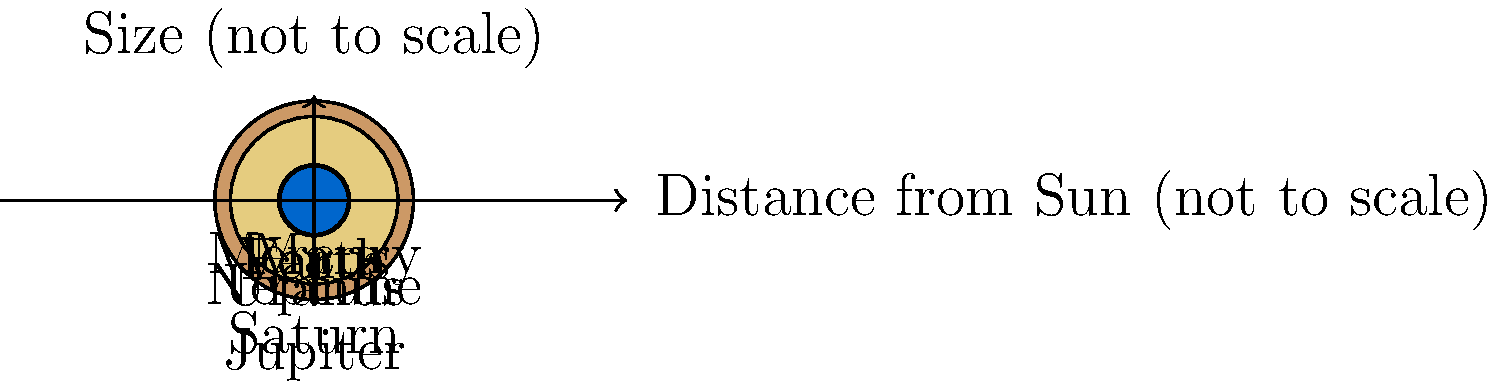As an entrepreneur in the food and beverage industry, you're considering expanding your roastery business to include space-themed coffee blends. To create an engaging marketing campaign, you need to understand the relative sizes and distances of planets in our solar system. Based on the diagram, which planet is both the largest and the farthest from the Sun? Let's approach this step-by-step:

1. First, we need to identify the largest planet:
   - Looking at the sizes of the planets in the diagram, we can see that Jupiter is the largest, followed by Saturn.
   - The actual diameters (in thousands of km) are: Jupiter (142.9), Saturn (120.5), Uranus (51.1), Neptune (49.5), Earth (12.8), Venus (12.1), Mars (6.8), Mercury (4.9).

2. Next, we need to determine the planet farthest from the Sun:
   - The diagram shows the relative distances, but not to scale.
   - The actual distances from the Sun (in millions of km) are: Mercury (57.9), Venus (108.2), Earth (149.6), Mars (227.9), Jupiter (778.5), Saturn (1434.0), Uranus (2871.0), Neptune (4495.0).
   - From this, we can see that Neptune is the farthest planet from the Sun.

3. Comparing our findings:
   - Jupiter is the largest planet but it's not the farthest from the Sun.
   - Neptune is the farthest planet from the Sun but it's not the largest.

Therefore, there is no planet that is both the largest and the farthest from the Sun.
Answer: None. Jupiter is largest, Neptune is farthest. 